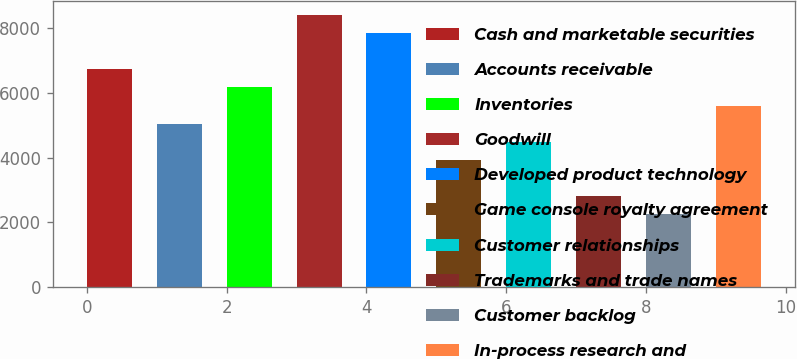Convert chart. <chart><loc_0><loc_0><loc_500><loc_500><bar_chart><fcel>Cash and marketable securities<fcel>Accounts receivable<fcel>Inventories<fcel>Goodwill<fcel>Developed product technology<fcel>Game console royalty agreement<fcel>Customer relationships<fcel>Trademarks and trade names<fcel>Customer backlog<fcel>In-process research and<nl><fcel>6724.4<fcel>5043.8<fcel>6164.2<fcel>8405<fcel>7844.8<fcel>3923.4<fcel>4483.6<fcel>2803<fcel>2242.8<fcel>5604<nl></chart> 